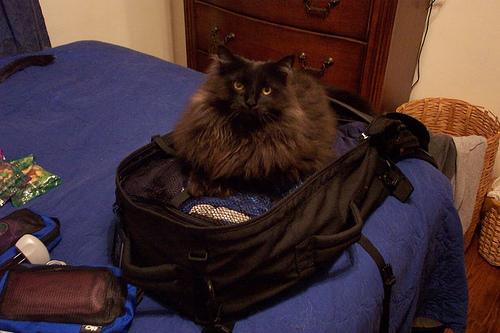Is there a cup on the nightstand?
Be succinct. No. What color is the sheets?
Keep it brief. Blue. Is this cat long haired or short haired?
Concise answer only. Long. Where is the cat?
Be succinct. Suitcase. What is the cat looking at?
Write a very short answer. Camera. Did the cat go on a trip?
Concise answer only. No. What is the blue object?
Concise answer only. Blanket. Is this a Persian cat?
Write a very short answer. Yes. 